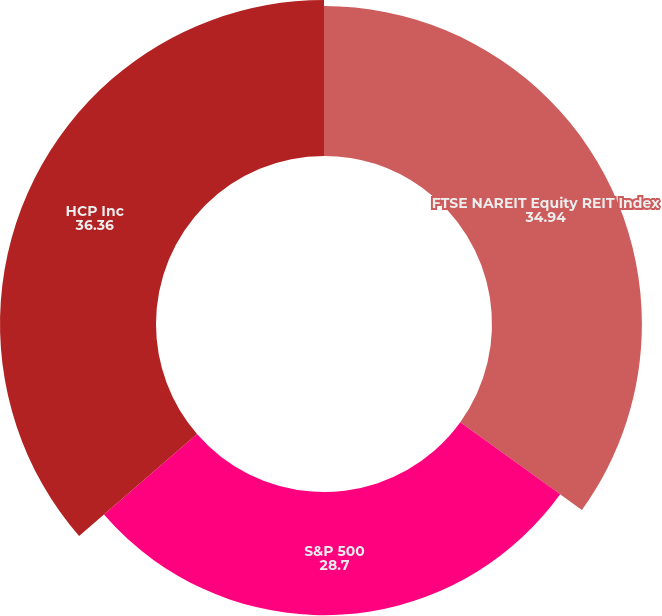Convert chart to OTSL. <chart><loc_0><loc_0><loc_500><loc_500><pie_chart><fcel>FTSE NAREIT Equity REIT Index<fcel>S&P 500<fcel>HCP Inc<nl><fcel>34.94%<fcel>28.7%<fcel>36.36%<nl></chart> 